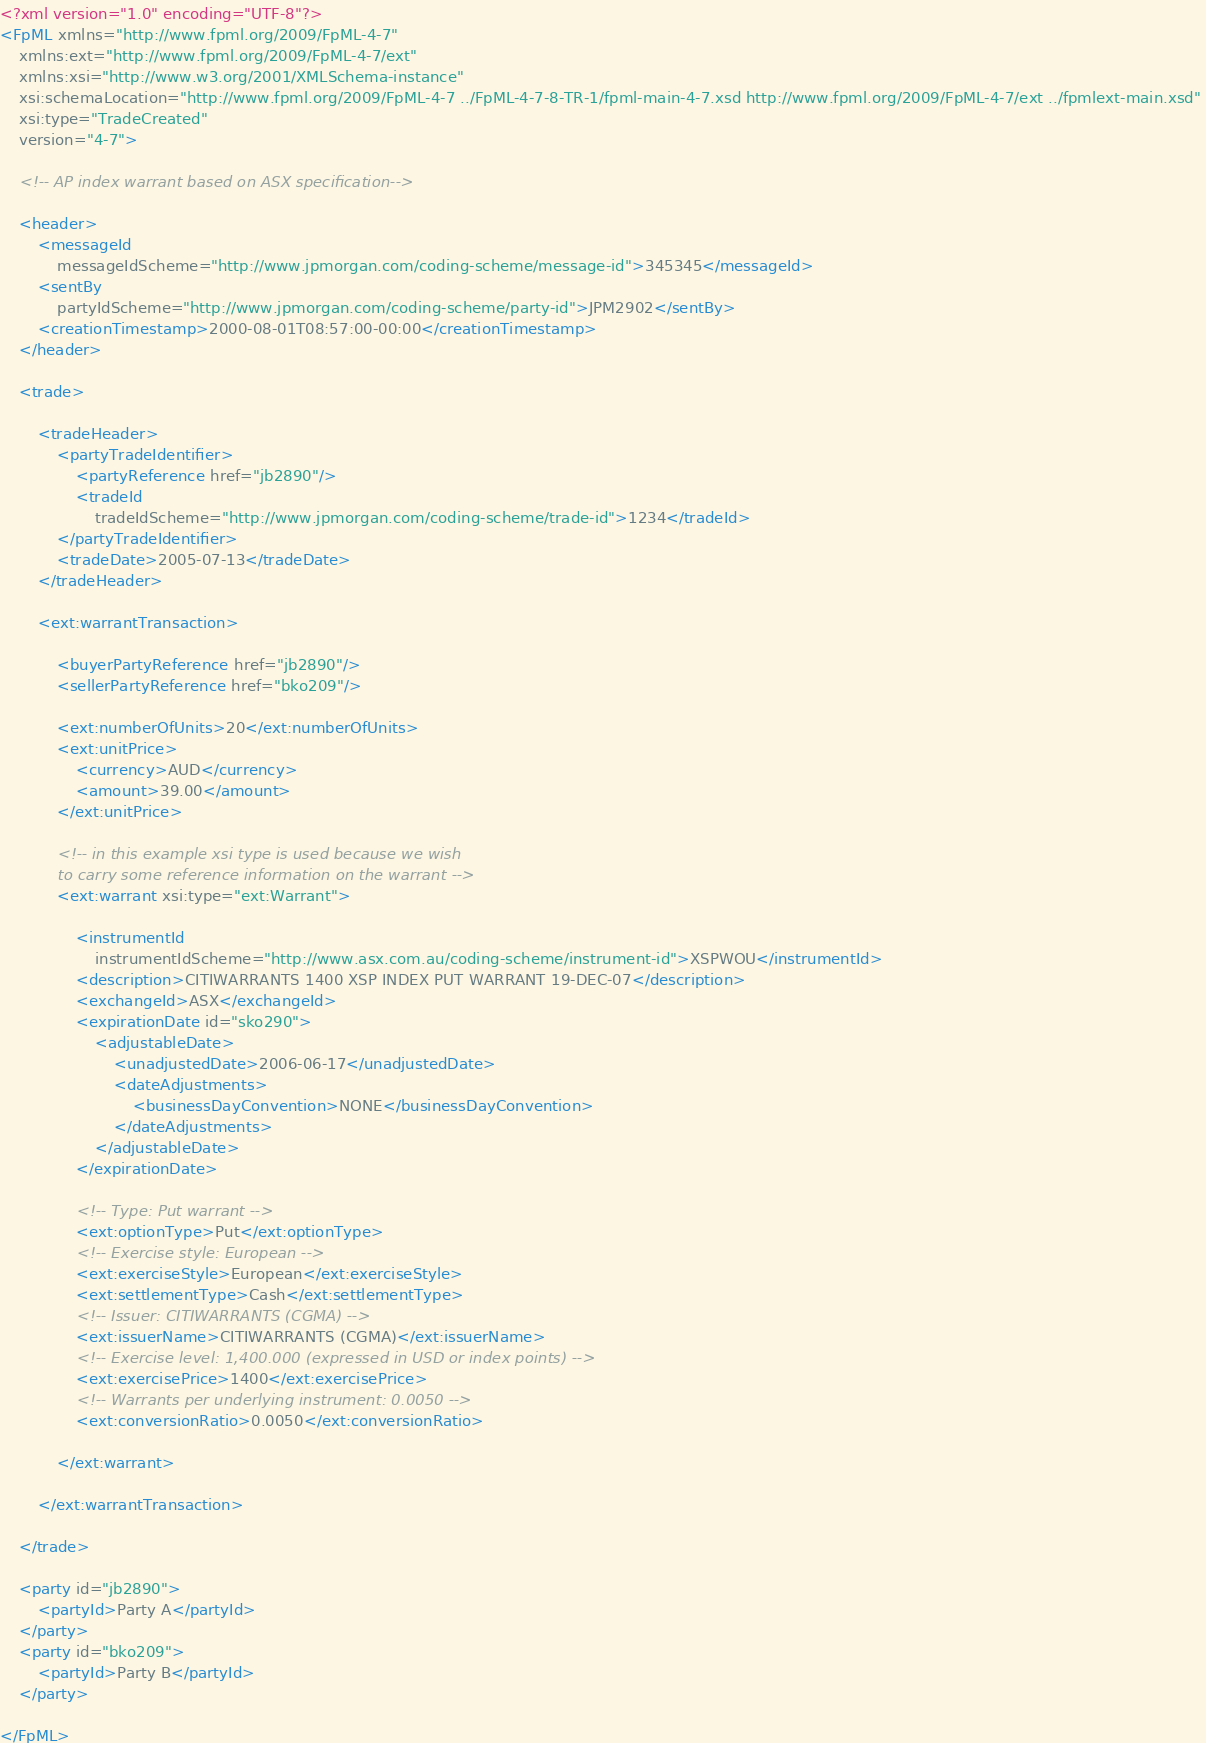Convert code to text. <code><loc_0><loc_0><loc_500><loc_500><_XML_><?xml version="1.0" encoding="UTF-8"?>
<FpML xmlns="http://www.fpml.org/2009/FpML-4-7" 
	xmlns:ext="http://www.fpml.org/2009/FpML-4-7/ext" 
	xmlns:xsi="http://www.w3.org/2001/XMLSchema-instance" 
	xsi:schemaLocation="http://www.fpml.org/2009/FpML-4-7 ../FpML-4-7-8-TR-1/fpml-main-4-7.xsd http://www.fpml.org/2009/FpML-4-7/ext ../fpmlext-main.xsd" 
	xsi:type="TradeCreated" 
	version="4-7">
	
	<!-- AP index warrant based on ASX specification-->
	
	<header>
		<messageId 
			messageIdScheme="http://www.jpmorgan.com/coding-scheme/message-id">345345</messageId>
		<sentBy 
			partyIdScheme="http://www.jpmorgan.com/coding-scheme/party-id">JPM2902</sentBy>
		<creationTimestamp>2000-08-01T08:57:00-00:00</creationTimestamp>
	</header>
	
	<trade>
	
		<tradeHeader>
			<partyTradeIdentifier>
				<partyReference href="jb2890"/>
				<tradeId 
					tradeIdScheme="http://www.jpmorgan.com/coding-scheme/trade-id">1234</tradeId>
			</partyTradeIdentifier>
			<tradeDate>2005-07-13</tradeDate>
		</tradeHeader>
		
		<ext:warrantTransaction>
		
			<buyerPartyReference href="jb2890"/>
			<sellerPartyReference href="bko209"/>
			
			<ext:numberOfUnits>20</ext:numberOfUnits>
			<ext:unitPrice>
				<currency>AUD</currency>
				<amount>39.00</amount>
			</ext:unitPrice>

			<!-- in this example xsi type is used because we wish
			to carry some reference information on the warrant -->
			<ext:warrant xsi:type="ext:Warrant">
			
				<instrumentId
					instrumentIdScheme="http://www.asx.com.au/coding-scheme/instrument-id">XSPWOU</instrumentId>
				<description>CITIWARRANTS 1400 XSP INDEX PUT WARRANT 19-DEC-07</description>
				<exchangeId>ASX</exchangeId>
				<expirationDate id="sko290">
					<adjustableDate>
						<unadjustedDate>2006-06-17</unadjustedDate>
						<dateAdjustments>
							<businessDayConvention>NONE</businessDayConvention>
						</dateAdjustments>
					</adjustableDate>
				</expirationDate>

				<!-- Type: Put warrant -->
				<ext:optionType>Put</ext:optionType>
				<!-- Exercise style: European -->
				<ext:exerciseStyle>European</ext:exerciseStyle>
				<ext:settlementType>Cash</ext:settlementType>
				<!-- Issuer: CITIWARRANTS (CGMA) -->
				<ext:issuerName>CITIWARRANTS (CGMA)</ext:issuerName>
				<!-- Exercise level: 1,400.000 (expressed in USD or index points) -->
				<ext:exercisePrice>1400</ext:exercisePrice>
				<!-- Warrants per underlying instrument: 0.0050 -->
				<ext:conversionRatio>0.0050</ext:conversionRatio>
				
			</ext:warrant>
			
		</ext:warrantTransaction>

	</trade>
	
	<party id="jb2890">
		<partyId>Party A</partyId>
	</party>
	<party id="bko209">
		<partyId>Party B</partyId>
	</party>
	
</FpML>
</code> 